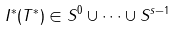<formula> <loc_0><loc_0><loc_500><loc_500>I ^ { * } ( T ^ { * } ) \in S ^ { 0 } \cup \dots \cup S ^ { s - 1 }</formula> 